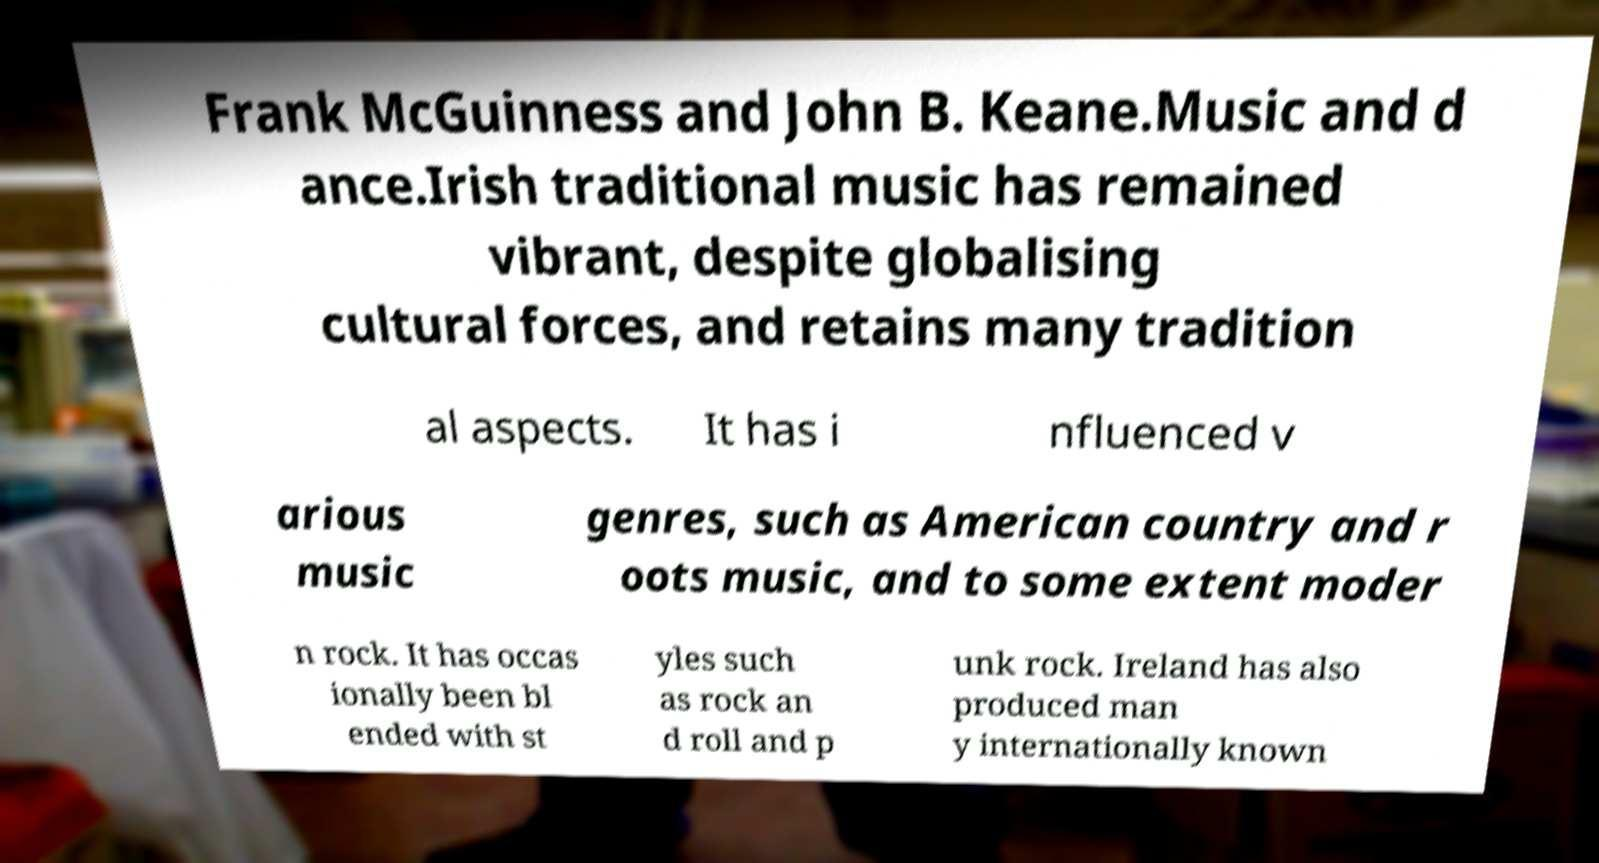Could you extract and type out the text from this image? Frank McGuinness and John B. Keane.Music and d ance.Irish traditional music has remained vibrant, despite globalising cultural forces, and retains many tradition al aspects. It has i nfluenced v arious music genres, such as American country and r oots music, and to some extent moder n rock. It has occas ionally been bl ended with st yles such as rock an d roll and p unk rock. Ireland has also produced man y internationally known 